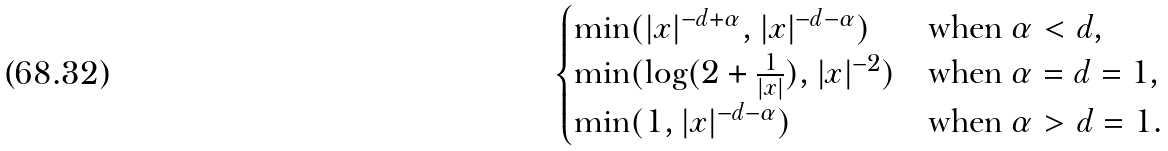Convert formula to latex. <formula><loc_0><loc_0><loc_500><loc_500>\begin{cases} \min ( | x | ^ { - d + \alpha } , | x | ^ { - d - \alpha } ) & \text {when $\alpha < d$,} \\ \min ( \log ( 2 + \frac { 1 } { | x | } ) , | x | ^ { - 2 } ) & \text {when $\alpha = d = 1$,} \\ \min ( 1 , | x | ^ { - d - \alpha } ) & \text {when $\alpha > d = 1$.} \end{cases}</formula> 